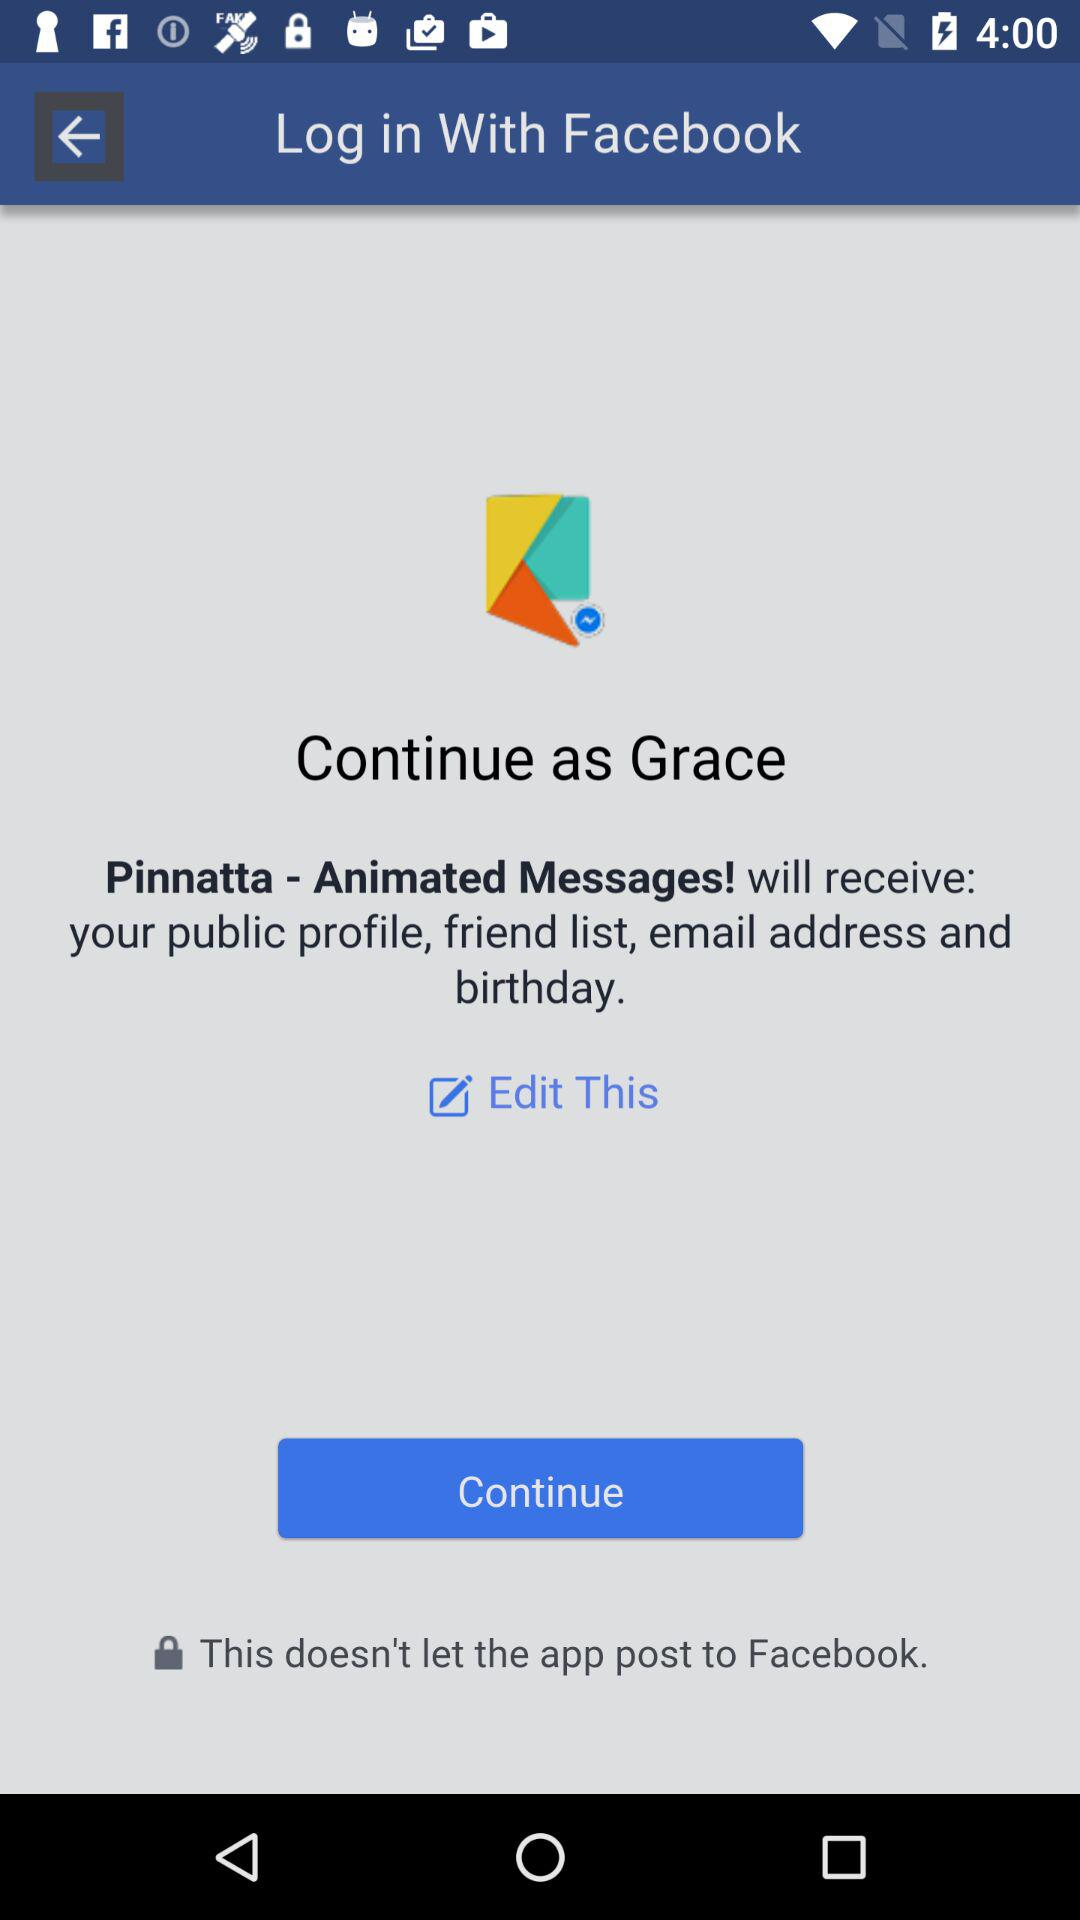Through what account login can be done? The login can be done through "Facebook". 